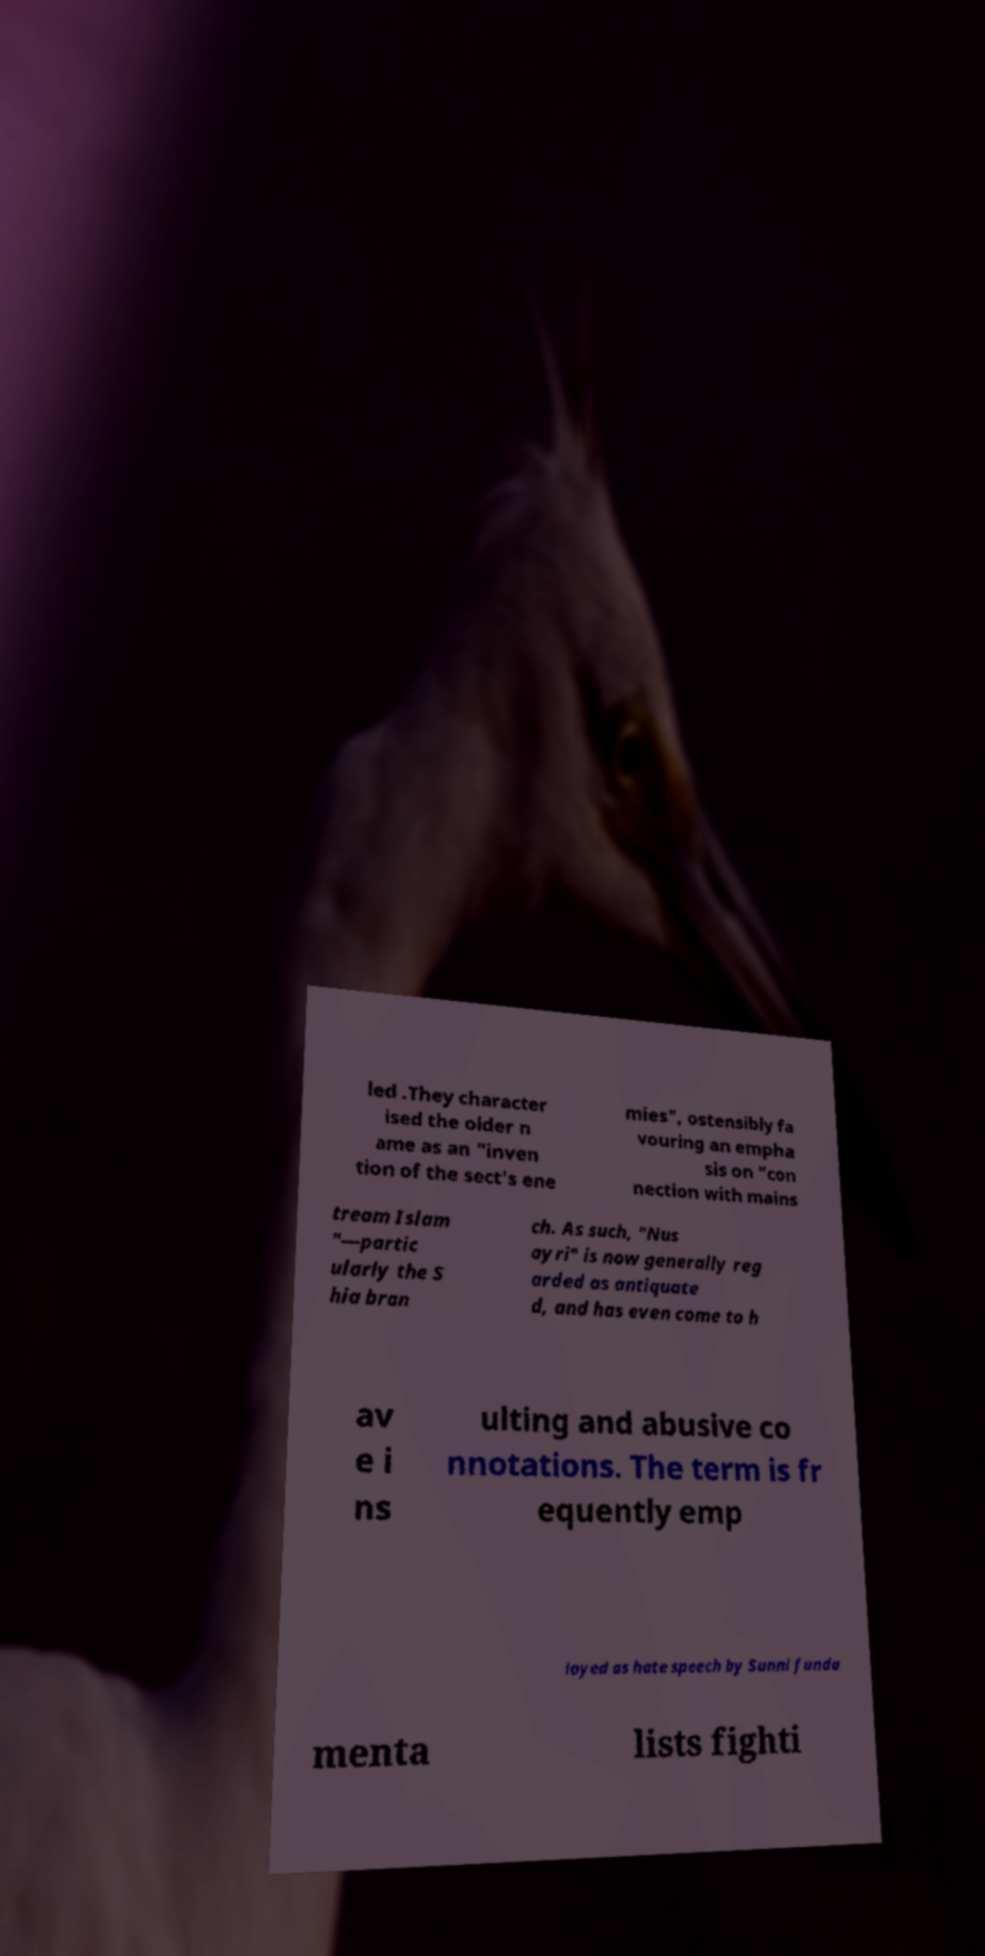What messages or text are displayed in this image? I need them in a readable, typed format. led .They character ised the older n ame as an "inven tion of the sect's ene mies", ostensibly fa vouring an empha sis on "con nection with mains tream Islam "—partic ularly the S hia bran ch. As such, "Nus ayri" is now generally reg arded as antiquate d, and has even come to h av e i ns ulting and abusive co nnotations. The term is fr equently emp loyed as hate speech by Sunni funda menta lists fighti 